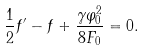<formula> <loc_0><loc_0><loc_500><loc_500>\frac { 1 } { 2 } f ^ { \prime } - f + \frac { \gamma \varphi _ { 0 } ^ { 2 } } { 8 F _ { 0 } } = 0 .</formula> 